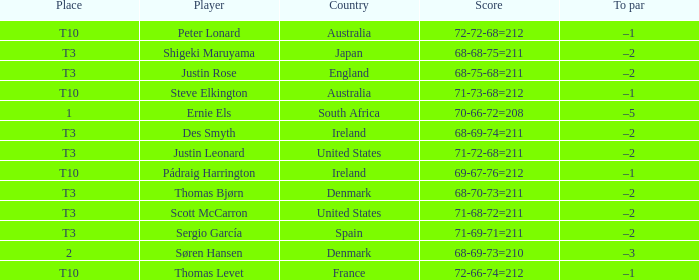What player scored 71-69-71=211? Sergio García. Can you give me this table as a dict? {'header': ['Place', 'Player', 'Country', 'Score', 'To par'], 'rows': [['T10', 'Peter Lonard', 'Australia', '72-72-68=212', '–1'], ['T3', 'Shigeki Maruyama', 'Japan', '68-68-75=211', '–2'], ['T3', 'Justin Rose', 'England', '68-75-68=211', '–2'], ['T10', 'Steve Elkington', 'Australia', '71-73-68=212', '–1'], ['1', 'Ernie Els', 'South Africa', '70-66-72=208', '–5'], ['T3', 'Des Smyth', 'Ireland', '68-69-74=211', '–2'], ['T3', 'Justin Leonard', 'United States', '71-72-68=211', '–2'], ['T10', 'Pádraig Harrington', 'Ireland', '69-67-76=212', '–1'], ['T3', 'Thomas Bjørn', 'Denmark', '68-70-73=211', '–2'], ['T3', 'Scott McCarron', 'United States', '71-68-72=211', '–2'], ['T3', 'Sergio García', 'Spain', '71-69-71=211', '–2'], ['2', 'Søren Hansen', 'Denmark', '68-69-73=210', '–3'], ['T10', 'Thomas Levet', 'France', '72-66-74=212', '–1']]} 